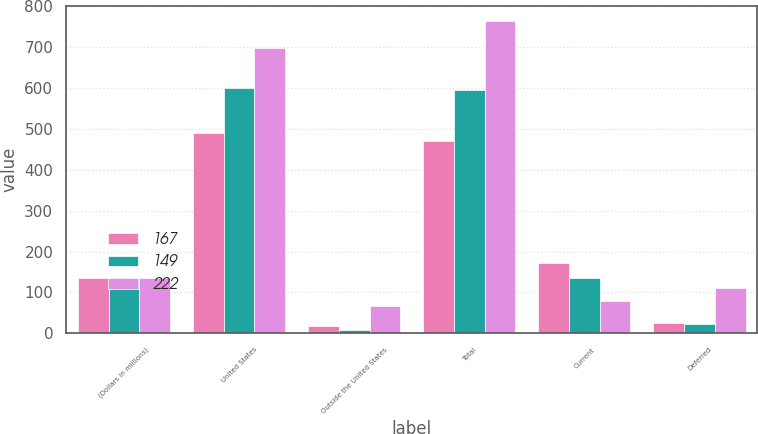<chart> <loc_0><loc_0><loc_500><loc_500><stacked_bar_chart><ecel><fcel>(Dollars in millions)<fcel>United States<fcel>Outside the United States<fcel>Total<fcel>Current<fcel>Deferred<nl><fcel>167<fcel>135<fcel>489<fcel>19<fcel>470<fcel>173<fcel>24<nl><fcel>149<fcel>135<fcel>601<fcel>7<fcel>594<fcel>135<fcel>22<nl><fcel>222<fcel>135<fcel>697<fcel>66<fcel>763<fcel>80<fcel>112<nl></chart> 